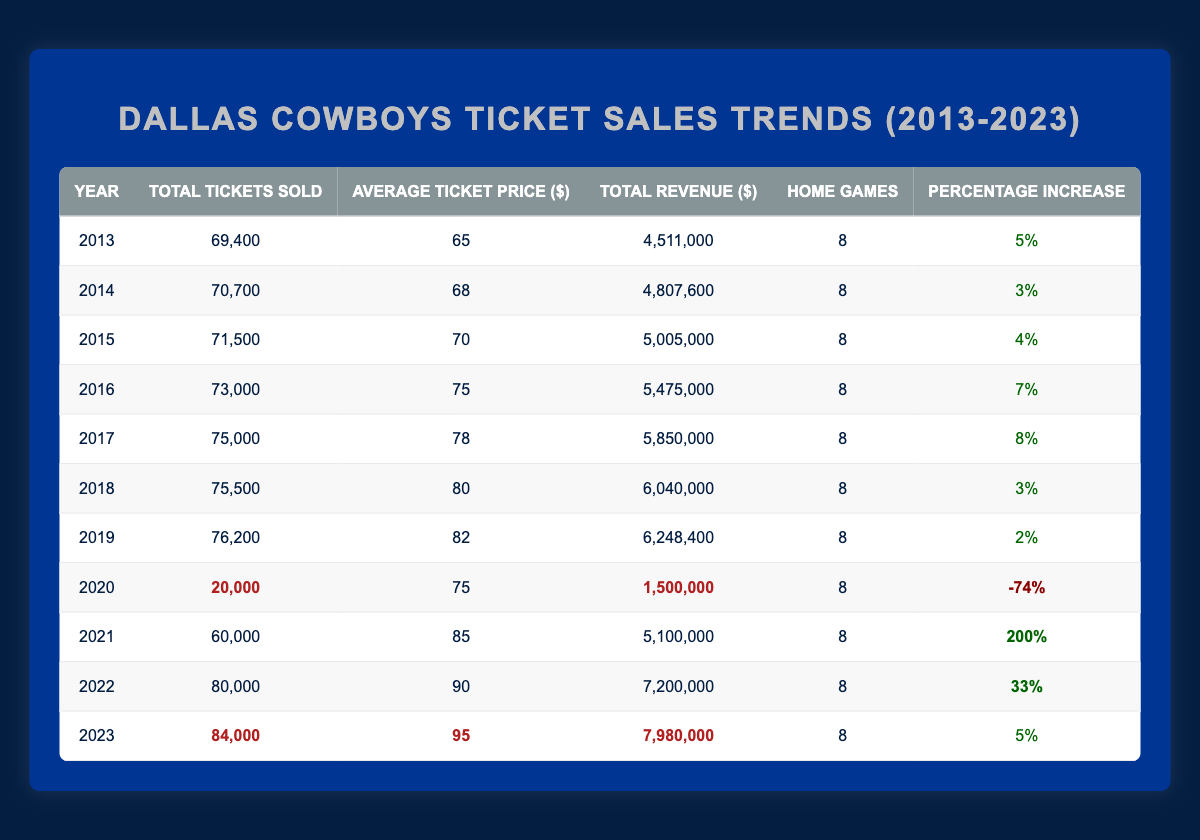What was the total revenue generated in 2022? The total revenue for the year 2022 is listed in the table as 7,200,000.
Answer: 7,200,000 What was the average ticket price in 2019? The average ticket price for the year 2019 is given as 82.
Answer: 82 In which year did ticket sales experience the highest percentage increase? The table shows that in 2021, the percentage increase was 200%, which is the highest among all years presented.
Answer: 2021 How many total tickets were sold in 2016? According to the table, in 2016, a total of 73,000 tickets were sold.
Answer: 73,000 What was the average ticket price over the last decade (2013-2022)? To find the average, sum all average ticket prices from 2013 to 2022, which is (65 + 68 + 70 + 75 + 78 + 80 + 82 + 75 + 85 + 90) = 818. Dividing by the number of years (10) gives 818/10 = 81.8.
Answer: 81.8 Did the Dallas Cowboys sell more than 80,000 tickets in 2021? In 2021, the total tickets sold are stated as 60,000, which is less than 80,000.
Answer: No What was the total ticket sales trend from the year 2019 to 2020? In 2019, the total tickets sold were 76,200, and in 2020, it dropped to 20,000, indicating a significant decrease.
Answer: Decrease Which year had the highest average ticket price and what was it? The year with the highest average ticket price is 2023 with an average ticket price of 95.
Answer: 2023, 95 What was the percentage increase from 2020 to 2021? In 2020, the percentage increase was -74%, while in 2021 it was 200%. The change from 2020 to 2021 represents a shift of 274 percentage points (200 - (-74)).
Answer: 274 percentage points How does the total number of tickets sold in 2022 compare to the total sold in 2018? In 2018, 75,500 tickets were sold while in 2022 that number increased to 80,000, showing an increase.
Answer: Increase What was the change in total revenue from 2013 to 2023? The revenue in 2013 was 4,511,000, and in 2023 it was 7,980,000. The change is calculated as 7,980,000 - 4,511,000 = 3,469,000, indicating an increase.
Answer: 3,469,000 increase 